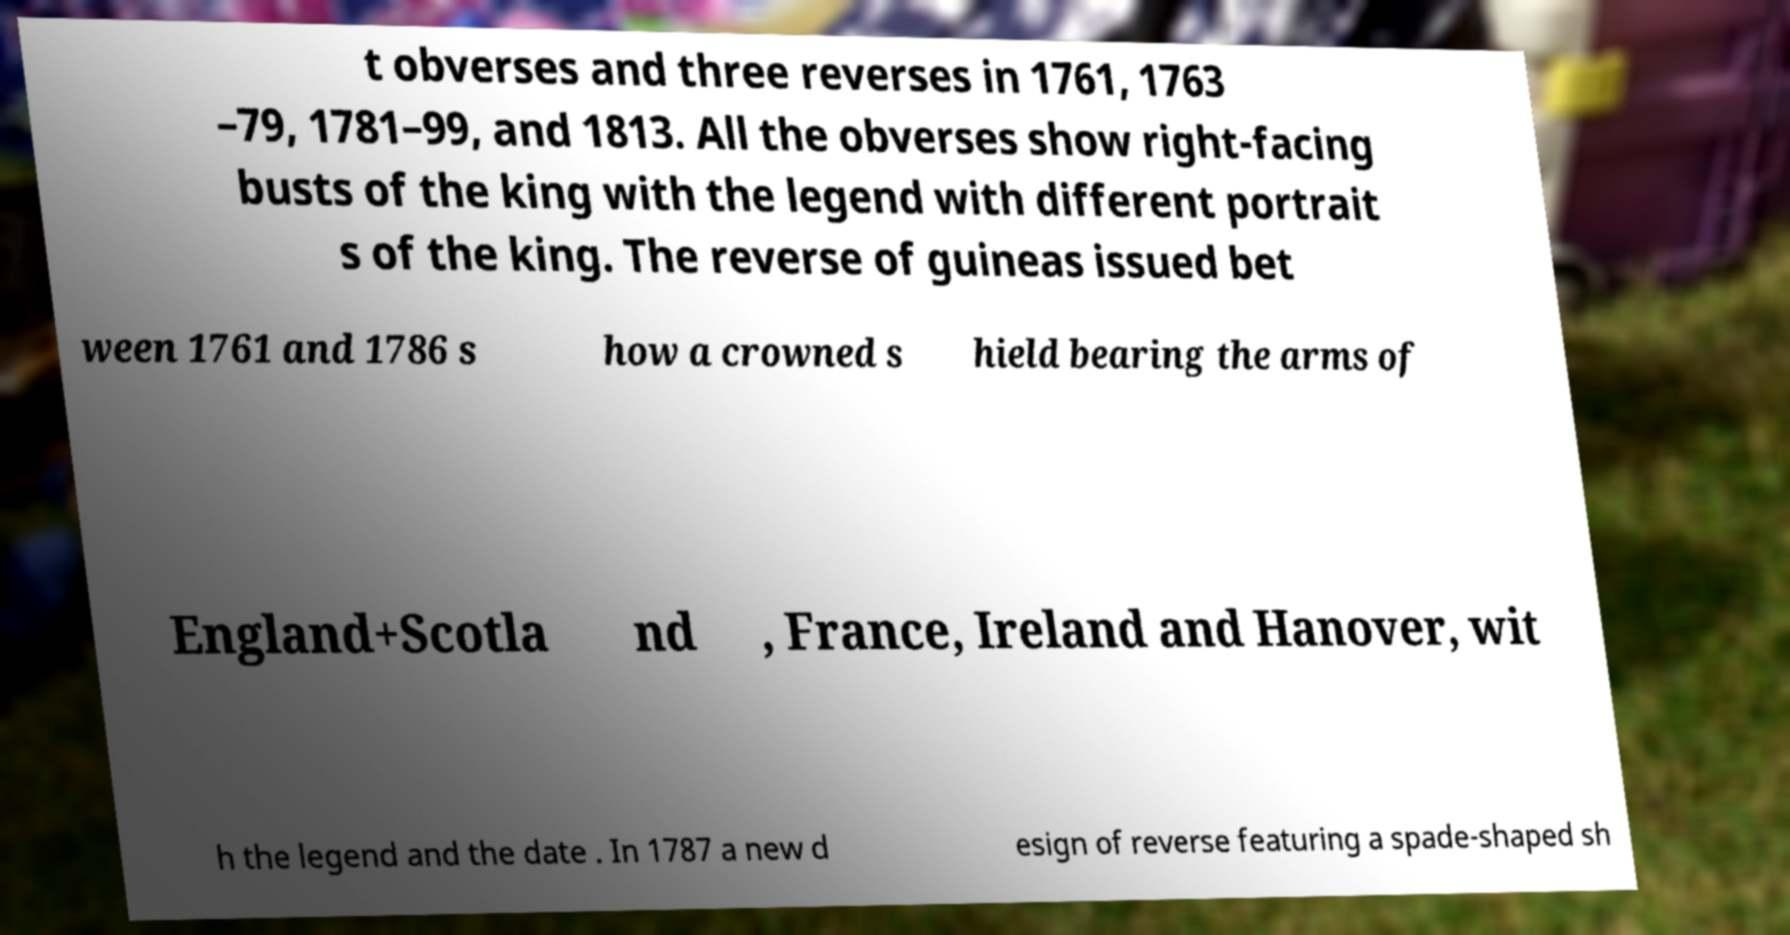I need the written content from this picture converted into text. Can you do that? t obverses and three reverses in 1761, 1763 –79, 1781–99, and 1813. All the obverses show right-facing busts of the king with the legend with different portrait s of the king. The reverse of guineas issued bet ween 1761 and 1786 s how a crowned s hield bearing the arms of England+Scotla nd , France, Ireland and Hanover, wit h the legend and the date . In 1787 a new d esign of reverse featuring a spade-shaped sh 